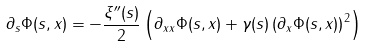<formula> <loc_0><loc_0><loc_500><loc_500>\partial _ { s } \Phi ( s , x ) & = - \frac { \xi ^ { \prime \prime } ( s ) } { 2 } \left ( \partial _ { x x } \Phi ( s , x ) + \gamma ( s ) \left ( \partial _ { x } \Phi ( s , x ) \right ) ^ { 2 } \right )</formula> 